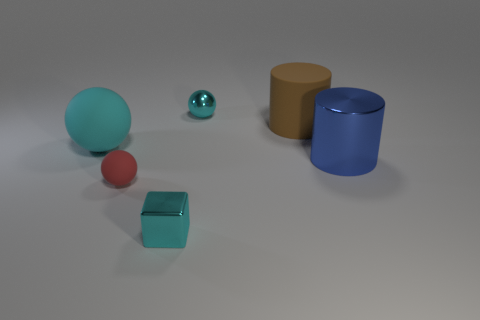Add 2 large blue shiny objects. How many objects exist? 8 Subtract all cubes. How many objects are left? 5 Add 2 tiny cyan balls. How many tiny cyan balls are left? 3 Add 4 tiny green shiny blocks. How many tiny green shiny blocks exist? 4 Subtract 0 gray cylinders. How many objects are left? 6 Subtract all small cyan blocks. Subtract all tiny cyan shiny things. How many objects are left? 3 